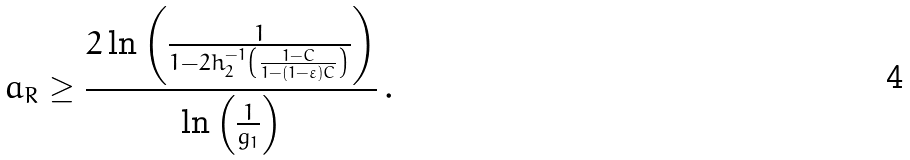Convert formula to latex. <formula><loc_0><loc_0><loc_500><loc_500>a _ { R } \geq \frac { 2 \ln \left ( \frac { 1 } { 1 - 2 h _ { 2 } ^ { - 1 } \left ( \frac { 1 - C } { 1 - ( 1 - \varepsilon ) C } \right ) } \right ) } { \ln \left ( \frac { 1 } { g _ { 1 } } \right ) } \, .</formula> 